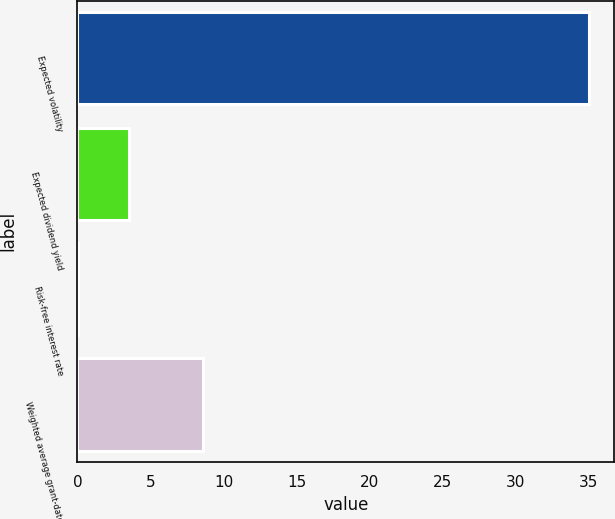Convert chart. <chart><loc_0><loc_0><loc_500><loc_500><bar_chart><fcel>Expected volatility<fcel>Expected dividend yield<fcel>Risk-free interest rate<fcel>Weighted average grant-date<nl><fcel>35<fcel>3.51<fcel>0.01<fcel>8.62<nl></chart> 